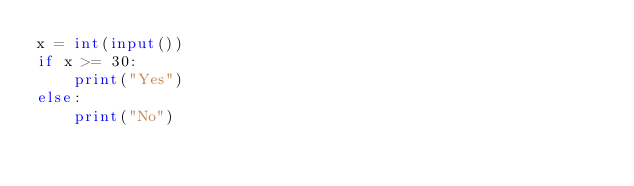<code> <loc_0><loc_0><loc_500><loc_500><_Python_>x = int(input())
if x >= 30:
    print("Yes")
else:
    print("No")</code> 